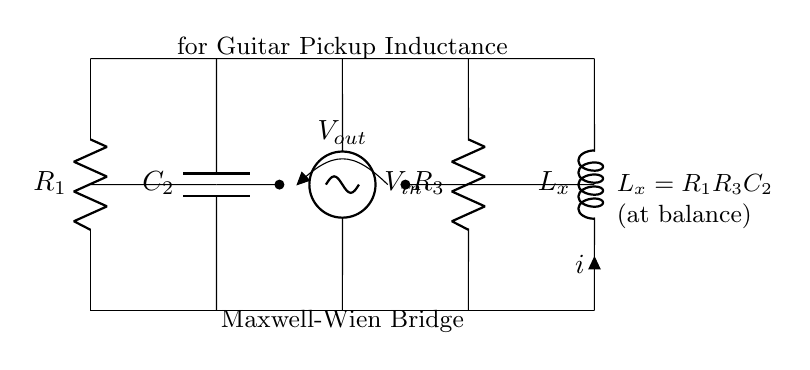What is the primary purpose of the Maxwell-Wien bridge? The Maxwell-Wien bridge is designed for measuring inductance, specifically in the context of guitar pickups in this circuit.
Answer: measuring inductance What component represents the unknown inductance in this circuit? The component labeled Lx represents the unknown inductance that is being measured in the bridge circuit.
Answer: Lx What is the function of R1 in this bridge? R1 is used to balance the bridge circuit, which is essential for accurately measuring the inductance at the point of balance.
Answer: balance What does the output voltage represent in the circuit? The output voltage Vout indicates the potential difference between the two points connected to the middle of the bridge, which helps determine if the bridge is balanced.
Answer: Vout What is the relationship between Lx, R1, R3, and C2 at balance? At balance, Lx equals the product of R1, R3, and C2, showing a mathematical relationship used for calculating the unknown inductance.
Answer: R1R3C2 When is the bridge considered balanced? The bridge is considered balanced when the output voltage Vout is zero, indicating equal potentials across the output terminals.
Answer: zero What type of circuit configuration does this setup represent? This setup specifically represents a bridge circuit configuration, which is commonly used for precision measurements.
Answer: bridge circuit 